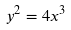<formula> <loc_0><loc_0><loc_500><loc_500>y ^ { 2 } = 4 x ^ { 3 }</formula> 